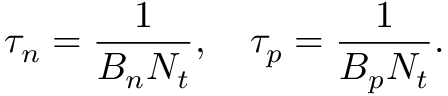<formula> <loc_0><loc_0><loc_500><loc_500>\tau _ { n } = { \frac { 1 } { B _ { n } N _ { t } } } , \quad \tau _ { p } = { \frac { 1 } { B _ { p } N _ { t } } } .</formula> 